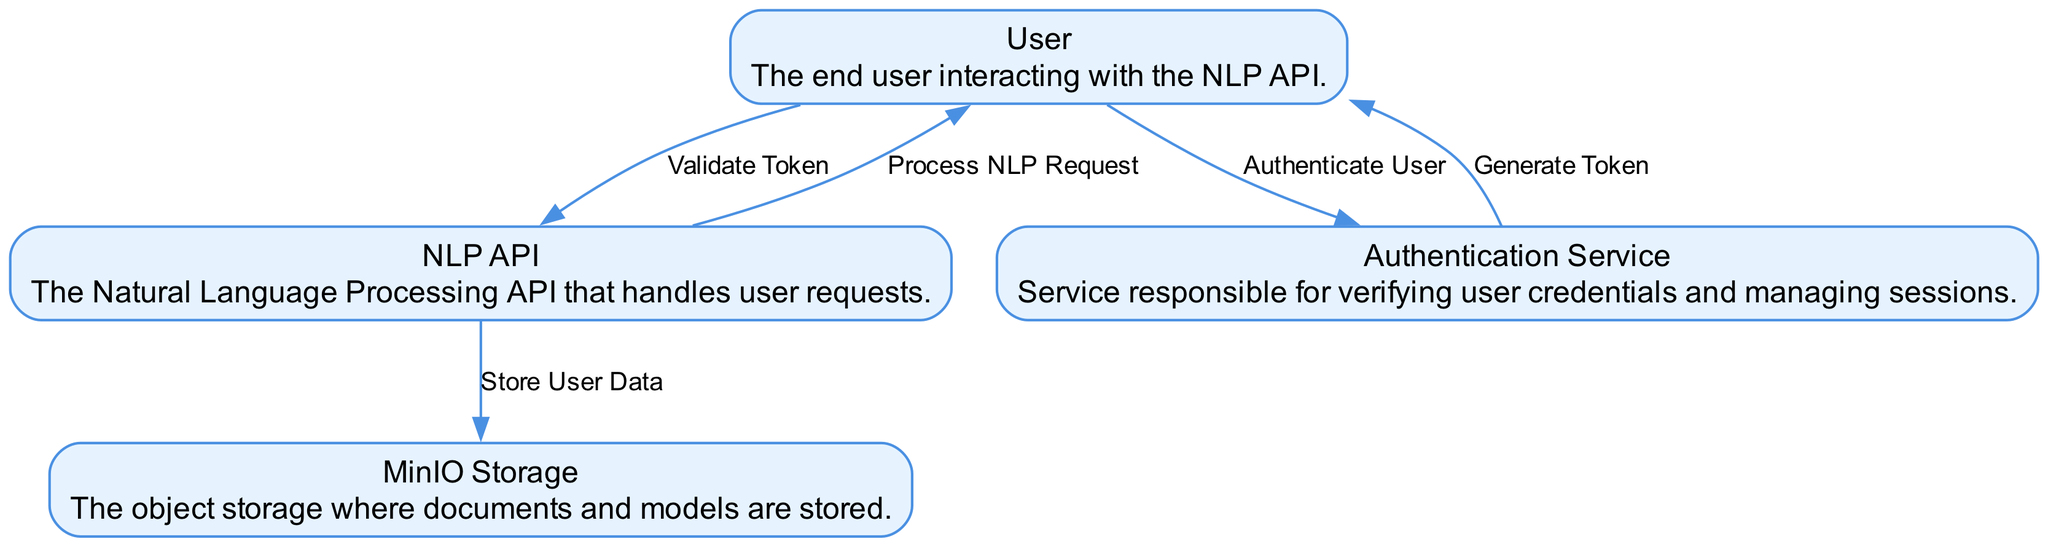What is the number of actors in the diagram? The diagram contains only one actor which is the User. Actors are typically represented at the top of the diagram, while systems and processes are arranged below them. Therefore, upon counting, we find there is exactly one actor.
Answer: 1 What is the relationship between the User and the Authentication Service? The User initiates the authentication flow by submitting their credentials to the Authentication Service. This is represented by a directed edge labeled "Authenticate User" from the User to the Authentication Service in the diagram.
Answer: Authenticate User How many processes are present in total? Upon examining the diagram's elements, one can identify five distinct processes: Authenticate User, Generate Token, Store User Data, Validate Token, and Process NLP Request. Each process is typically represented in a box and can be counted directly.
Answer: 5 Which component generates the access token? The Authentication Service is responsible for generating the access token after validating user credentials. This is shown in the diagram, where an edge labeled "Generate Token" is directed from the Authentication Service back to the User, indicating that the token is generated here.
Answer: Authentication Service What does the NLP API do after authenticating the user? After successful authentication, the NLP API takes user-related data and stores it in MinIO Storage, as indicated by the directed edge labeled "Store User Data" from the NLP API to MinIO Storage in the diagram.
Answer: Store User Data What must the User do before sending an NLP request? Before sending any NLP request, the User must first validate their access token, which is the step represented by the "Validate Token" process in the diagram. This is crucial for ensuring the legitimacy of the request.
Answer: Validate Token What is the final output of the process after a successful NLP request? The final output after processing an NLP request is sent back to the User from the NLP API, which is represented by a directed edge labeled "Process NLP Request." This illustrates the flow completion after the processing of the request.
Answer: Process NLP Request Which system stores user-related data? The system responsible for storing user-related data is MinIO Storage, as shown by the directed edge connecting the NLP API to MinIO Storage with the label "Store User Data," indicating that this is where the data is saved after authentication.
Answer: MinIO Storage What interaction happens after the User submits credentials? After the User submits their credentials to the Authentication Service, the next step is that the Authentication Service generates an access token and sends it back to the User, as indicated by the directed edge labeled "Generate Token." This flow is crucial for enabling subsequent interactions.
Answer: Generate Token 